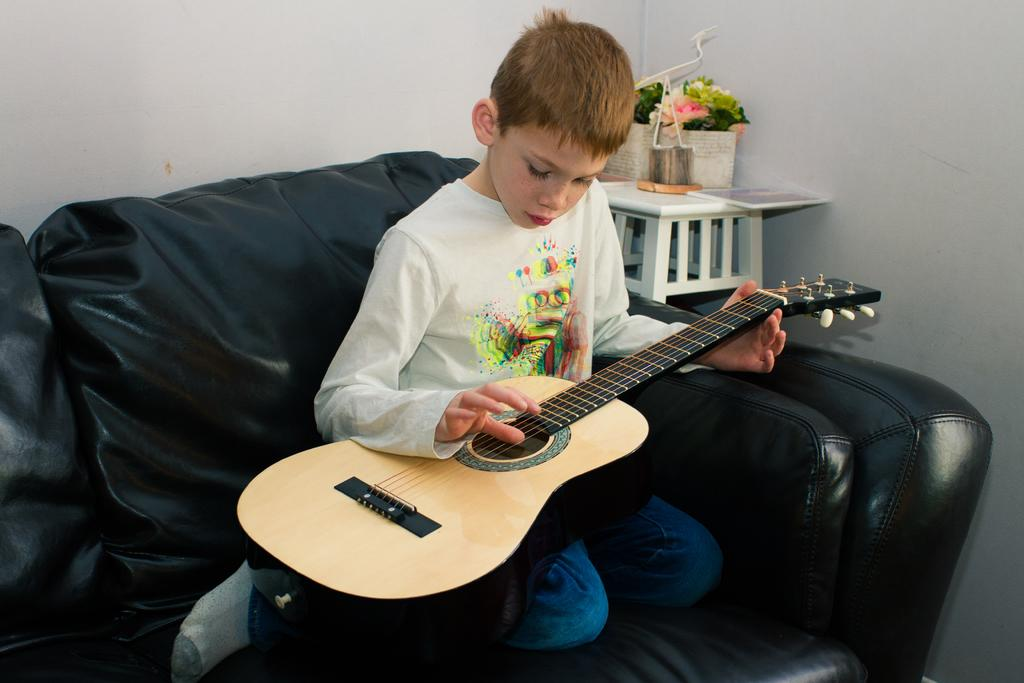What can be seen in the background of the image? There is a white wall in the background of the image. What piece of furniture is in the image? There is a table in the image. What is placed on the table? Flower pots are present on the table. What type of seating is in the image? There is a black sofa in the image. Who is sitting on the black sofa? A boy is sitting on the black sofa. What is the boy doing while sitting on the sofa? The boy is playing a guitar. Where is the rabbit playing on the farm in the image? There is no rabbit or farm present in the image. Can you touch the white wall in the image? You cannot touch the white wall in the image, as it is a two-dimensional representation. 